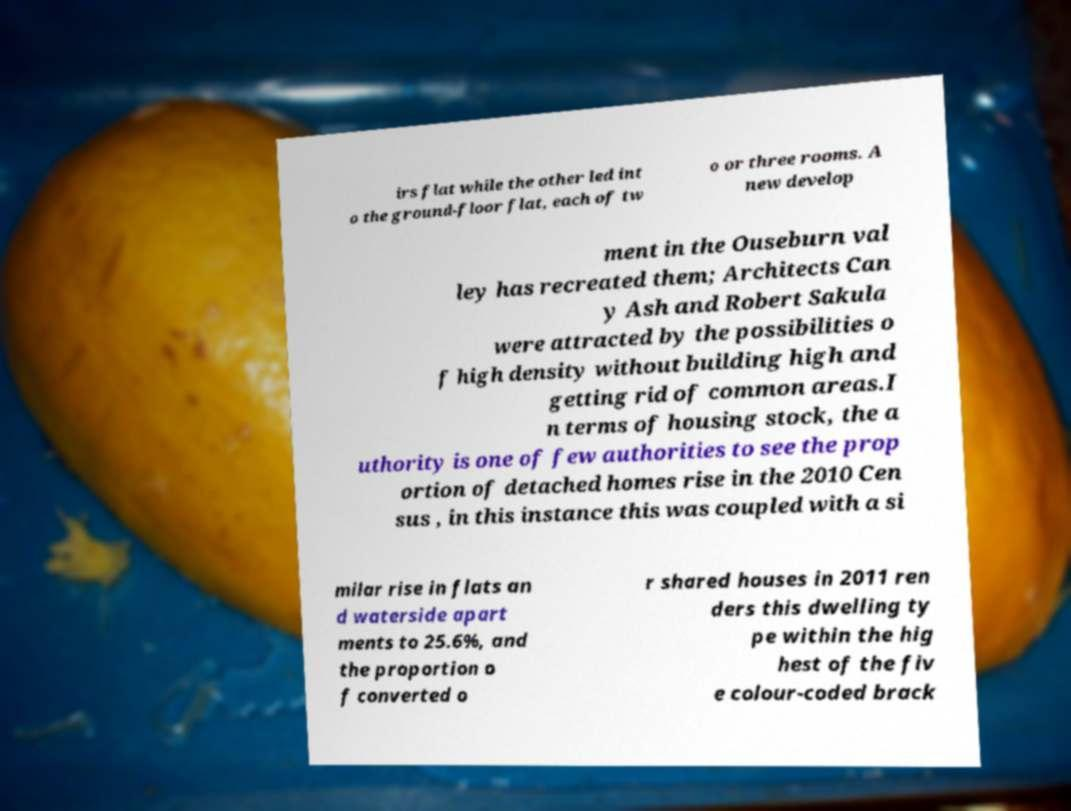Can you accurately transcribe the text from the provided image for me? irs flat while the other led int o the ground-floor flat, each of tw o or three rooms. A new develop ment in the Ouseburn val ley has recreated them; Architects Can y Ash and Robert Sakula were attracted by the possibilities o f high density without building high and getting rid of common areas.I n terms of housing stock, the a uthority is one of few authorities to see the prop ortion of detached homes rise in the 2010 Cen sus , in this instance this was coupled with a si milar rise in flats an d waterside apart ments to 25.6%, and the proportion o f converted o r shared houses in 2011 ren ders this dwelling ty pe within the hig hest of the fiv e colour-coded brack 